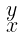<formula> <loc_0><loc_0><loc_500><loc_500>\begin{smallmatrix} y \\ x \end{smallmatrix}</formula> 